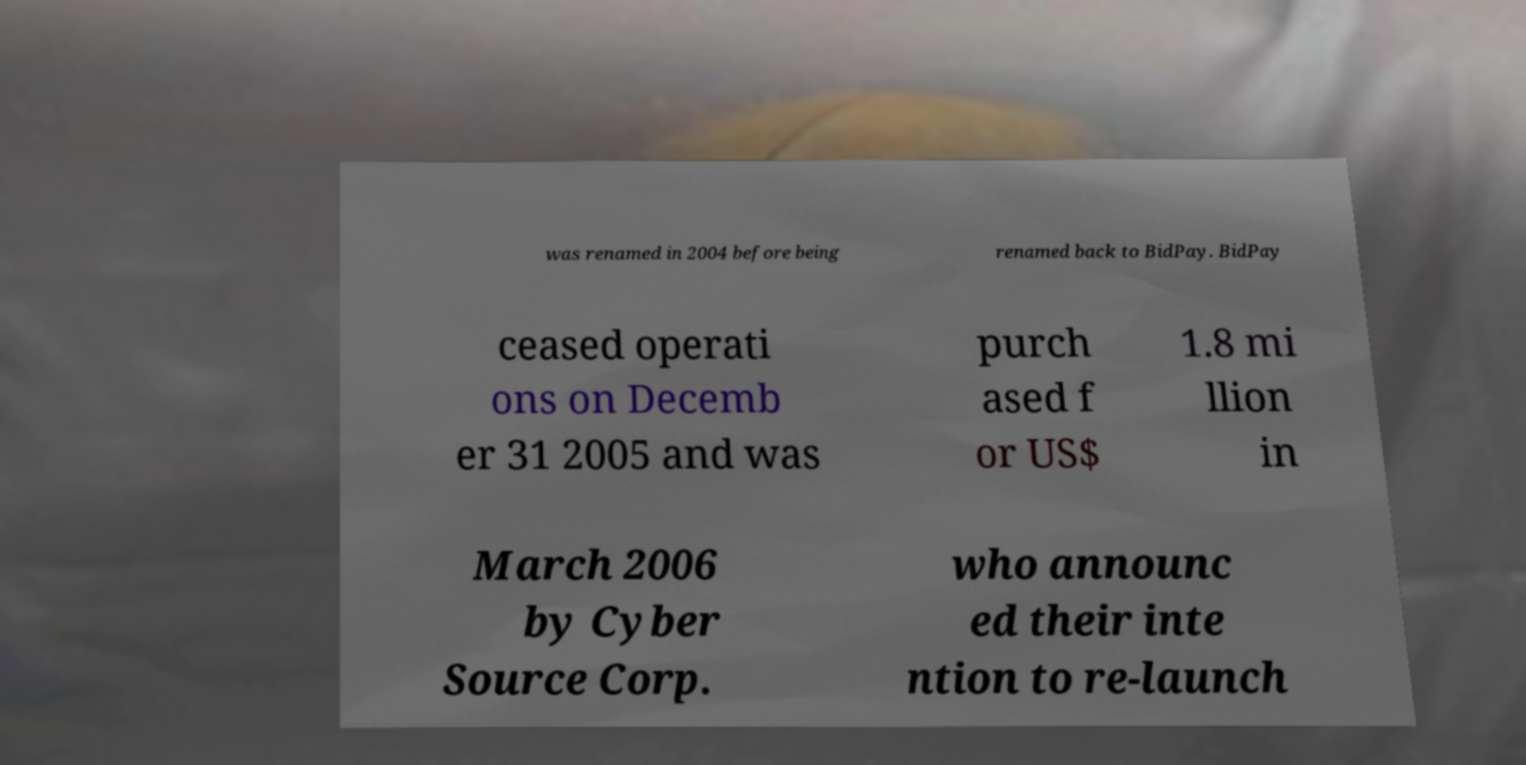There's text embedded in this image that I need extracted. Can you transcribe it verbatim? was renamed in 2004 before being renamed back to BidPay. BidPay ceased operati ons on Decemb er 31 2005 and was purch ased f or US$ 1.8 mi llion in March 2006 by Cyber Source Corp. who announc ed their inte ntion to re-launch 